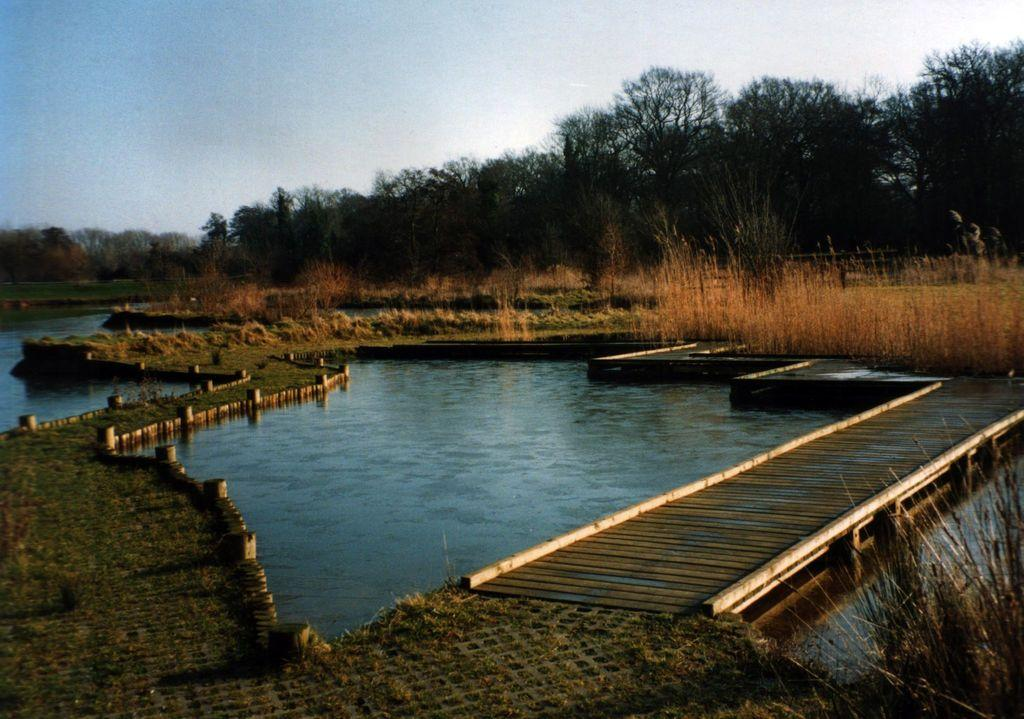What type of structure can be seen in the image? There is a wooden bridge in the image. What can be seen beneath the bridge? The ground is visible in the image. What type of vegetation is present in the image? There is grass in the image. What natural element is present in the image? There is water in the image. What can be seen in the background of the image? There are trees and the sky visible in the background of the image. How many women are playing basketball on the wooden bridge in the image? There are no women or basketballs present in the image; it features a wooden bridge, ground, grass, water, trees, and the sky. 